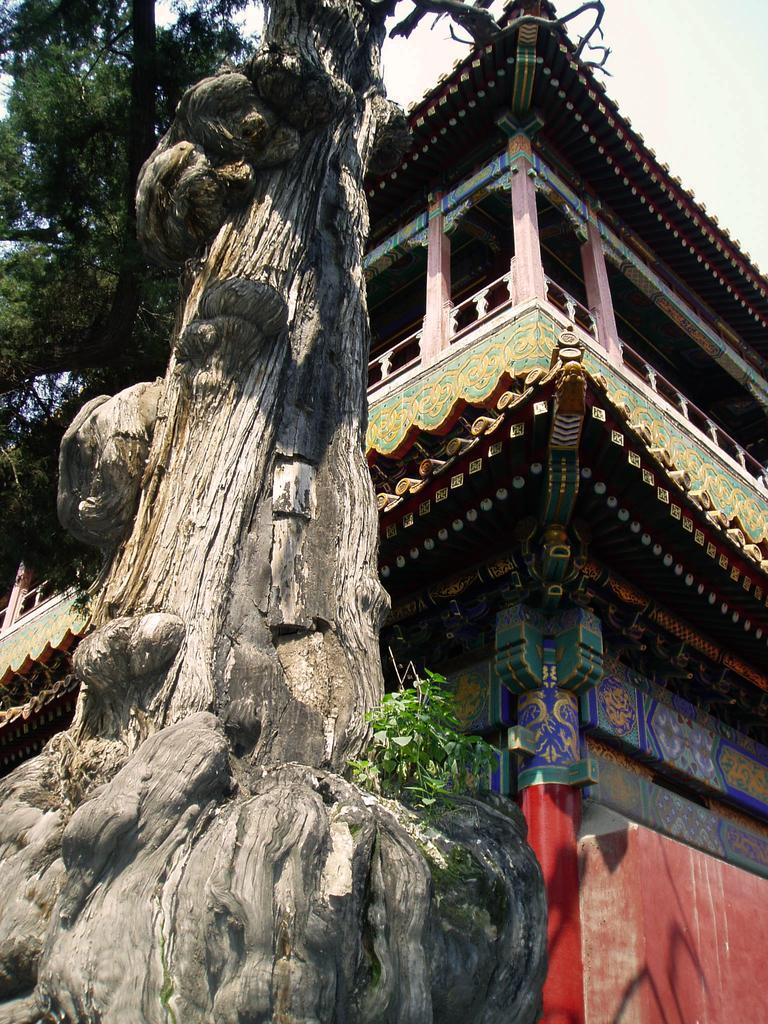Please provide a concise description of this image. In this image I can see a building in multicolor. Background I can see few trees in green color and sky in white color. 